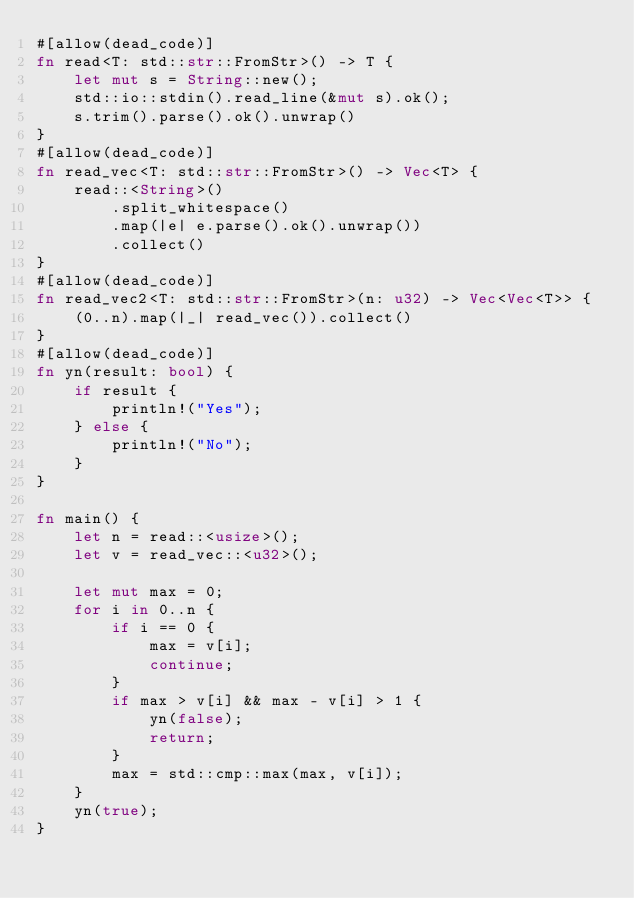Convert code to text. <code><loc_0><loc_0><loc_500><loc_500><_Rust_>#[allow(dead_code)]
fn read<T: std::str::FromStr>() -> T {
    let mut s = String::new();
    std::io::stdin().read_line(&mut s).ok();
    s.trim().parse().ok().unwrap()
}
#[allow(dead_code)]
fn read_vec<T: std::str::FromStr>() -> Vec<T> {
    read::<String>()
        .split_whitespace()
        .map(|e| e.parse().ok().unwrap())
        .collect()
}
#[allow(dead_code)]
fn read_vec2<T: std::str::FromStr>(n: u32) -> Vec<Vec<T>> {
    (0..n).map(|_| read_vec()).collect()
}
#[allow(dead_code)]
fn yn(result: bool) {
    if result {
        println!("Yes");
    } else {
        println!("No");
    }
}

fn main() {
    let n = read::<usize>();
    let v = read_vec::<u32>();

    let mut max = 0;
    for i in 0..n {
        if i == 0 {
            max = v[i];
            continue;
        }
        if max > v[i] && max - v[i] > 1 {
            yn(false);
            return;
        }
        max = std::cmp::max(max, v[i]);
    }
    yn(true);
}
</code> 